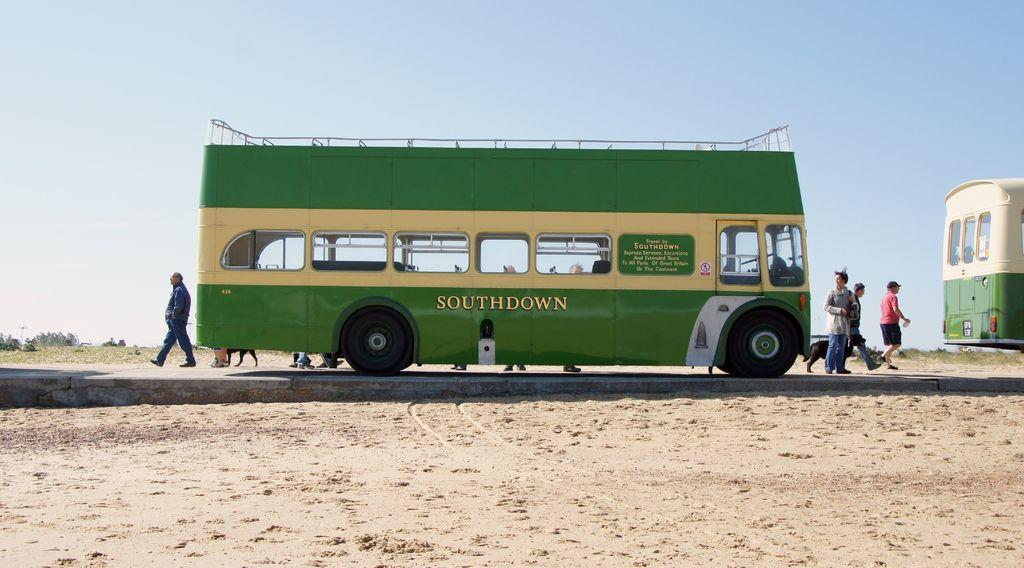<image>
Give a short and clear explanation of the subsequent image. The Southdown bus is green and cream and has an deck on the roof. 